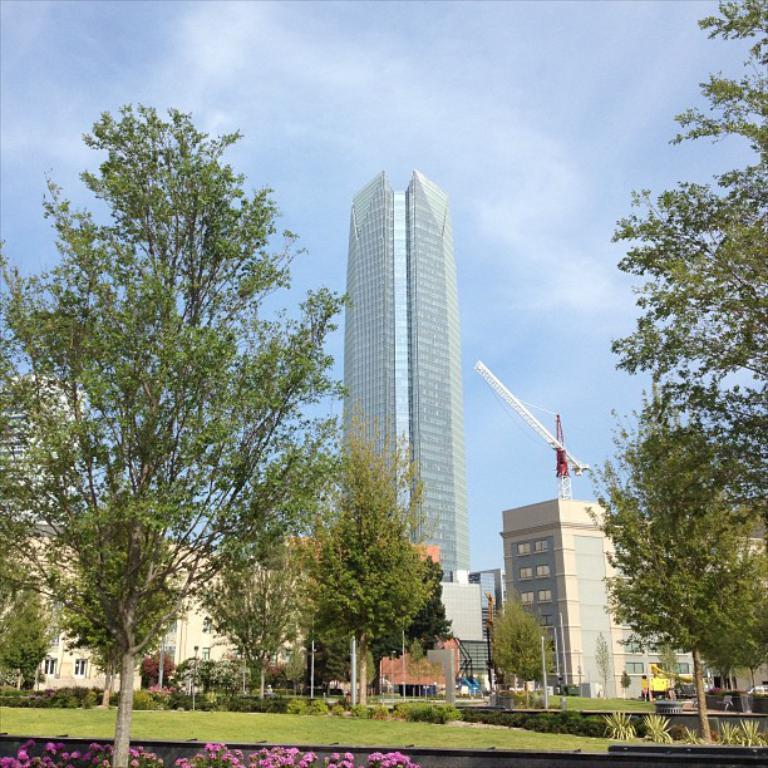What types of structures are visible in the image? There are buildings and houses in the image. What else can be seen in the image besides structures? There are trees and plants with flowers in the image. What type of cheese is being used to decorate the goose in the image? There is no goose or cheese present in the image. 